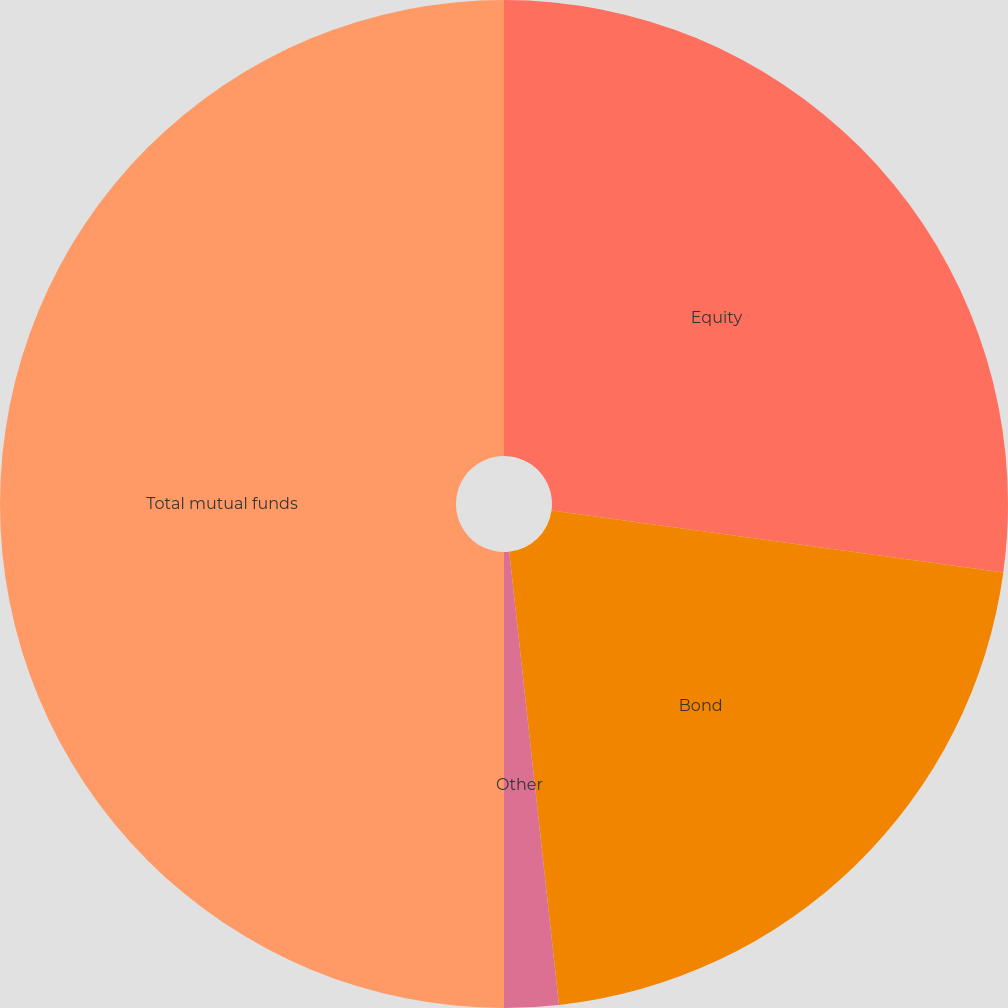Convert chart to OTSL. <chart><loc_0><loc_0><loc_500><loc_500><pie_chart><fcel>Equity<fcel>Bond<fcel>Other<fcel>Total mutual funds<nl><fcel>27.17%<fcel>21.09%<fcel>1.74%<fcel>50.0%<nl></chart> 